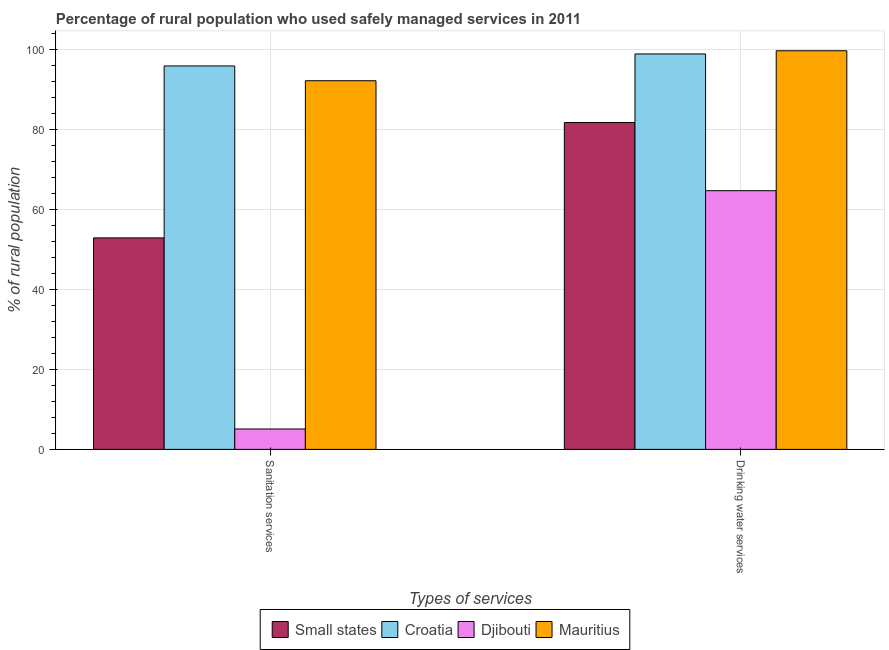How many different coloured bars are there?
Make the answer very short. 4. Are the number of bars on each tick of the X-axis equal?
Ensure brevity in your answer.  Yes. How many bars are there on the 2nd tick from the left?
Offer a very short reply. 4. How many bars are there on the 2nd tick from the right?
Your answer should be very brief. 4. What is the label of the 1st group of bars from the left?
Give a very brief answer. Sanitation services. What is the percentage of rural population who used sanitation services in Croatia?
Give a very brief answer. 95.9. Across all countries, what is the maximum percentage of rural population who used drinking water services?
Your answer should be very brief. 99.7. In which country was the percentage of rural population who used drinking water services maximum?
Make the answer very short. Mauritius. In which country was the percentage of rural population who used drinking water services minimum?
Keep it short and to the point. Djibouti. What is the total percentage of rural population who used sanitation services in the graph?
Your response must be concise. 246.1. What is the difference between the percentage of rural population who used drinking water services in Small states and that in Djibouti?
Your response must be concise. 17.06. What is the difference between the percentage of rural population who used sanitation services in Croatia and the percentage of rural population who used drinking water services in Small states?
Make the answer very short. 14.14. What is the average percentage of rural population who used drinking water services per country?
Provide a succinct answer. 86.26. What is the difference between the percentage of rural population who used drinking water services and percentage of rural population who used sanitation services in Croatia?
Offer a terse response. 3. In how many countries, is the percentage of rural population who used drinking water services greater than 44 %?
Offer a terse response. 4. What is the ratio of the percentage of rural population who used sanitation services in Djibouti to that in Small states?
Offer a terse response. 0.1. Is the percentage of rural population who used drinking water services in Small states less than that in Djibouti?
Keep it short and to the point. No. What does the 4th bar from the left in Drinking water services represents?
Provide a short and direct response. Mauritius. What does the 1st bar from the right in Drinking water services represents?
Provide a short and direct response. Mauritius. Are all the bars in the graph horizontal?
Give a very brief answer. No. What is the difference between two consecutive major ticks on the Y-axis?
Offer a terse response. 20. Does the graph contain any zero values?
Your answer should be compact. No. Where does the legend appear in the graph?
Offer a terse response. Bottom center. How many legend labels are there?
Offer a terse response. 4. How are the legend labels stacked?
Your answer should be compact. Horizontal. What is the title of the graph?
Your response must be concise. Percentage of rural population who used safely managed services in 2011. What is the label or title of the X-axis?
Keep it short and to the point. Types of services. What is the label or title of the Y-axis?
Your answer should be compact. % of rural population. What is the % of rural population of Small states in Sanitation services?
Offer a very short reply. 52.9. What is the % of rural population of Croatia in Sanitation services?
Ensure brevity in your answer.  95.9. What is the % of rural population in Mauritius in Sanitation services?
Offer a terse response. 92.2. What is the % of rural population of Small states in Drinking water services?
Your answer should be very brief. 81.76. What is the % of rural population in Croatia in Drinking water services?
Offer a very short reply. 98.9. What is the % of rural population of Djibouti in Drinking water services?
Provide a short and direct response. 64.7. What is the % of rural population in Mauritius in Drinking water services?
Make the answer very short. 99.7. Across all Types of services, what is the maximum % of rural population of Small states?
Provide a short and direct response. 81.76. Across all Types of services, what is the maximum % of rural population of Croatia?
Your answer should be very brief. 98.9. Across all Types of services, what is the maximum % of rural population of Djibouti?
Provide a short and direct response. 64.7. Across all Types of services, what is the maximum % of rural population in Mauritius?
Provide a short and direct response. 99.7. Across all Types of services, what is the minimum % of rural population in Small states?
Your answer should be compact. 52.9. Across all Types of services, what is the minimum % of rural population in Croatia?
Your answer should be very brief. 95.9. Across all Types of services, what is the minimum % of rural population of Djibouti?
Offer a very short reply. 5.1. Across all Types of services, what is the minimum % of rural population in Mauritius?
Give a very brief answer. 92.2. What is the total % of rural population in Small states in the graph?
Ensure brevity in your answer.  134.66. What is the total % of rural population in Croatia in the graph?
Offer a terse response. 194.8. What is the total % of rural population in Djibouti in the graph?
Offer a very short reply. 69.8. What is the total % of rural population in Mauritius in the graph?
Offer a very short reply. 191.9. What is the difference between the % of rural population of Small states in Sanitation services and that in Drinking water services?
Give a very brief answer. -28.86. What is the difference between the % of rural population in Croatia in Sanitation services and that in Drinking water services?
Provide a succinct answer. -3. What is the difference between the % of rural population in Djibouti in Sanitation services and that in Drinking water services?
Keep it short and to the point. -59.6. What is the difference between the % of rural population of Small states in Sanitation services and the % of rural population of Croatia in Drinking water services?
Offer a very short reply. -46. What is the difference between the % of rural population of Small states in Sanitation services and the % of rural population of Djibouti in Drinking water services?
Offer a very short reply. -11.8. What is the difference between the % of rural population of Small states in Sanitation services and the % of rural population of Mauritius in Drinking water services?
Give a very brief answer. -46.8. What is the difference between the % of rural population in Croatia in Sanitation services and the % of rural population in Djibouti in Drinking water services?
Provide a short and direct response. 31.2. What is the difference between the % of rural population in Croatia in Sanitation services and the % of rural population in Mauritius in Drinking water services?
Your answer should be compact. -3.8. What is the difference between the % of rural population in Djibouti in Sanitation services and the % of rural population in Mauritius in Drinking water services?
Keep it short and to the point. -94.6. What is the average % of rural population in Small states per Types of services?
Your answer should be compact. 67.33. What is the average % of rural population in Croatia per Types of services?
Ensure brevity in your answer.  97.4. What is the average % of rural population in Djibouti per Types of services?
Make the answer very short. 34.9. What is the average % of rural population of Mauritius per Types of services?
Give a very brief answer. 95.95. What is the difference between the % of rural population of Small states and % of rural population of Croatia in Sanitation services?
Ensure brevity in your answer.  -43. What is the difference between the % of rural population of Small states and % of rural population of Djibouti in Sanitation services?
Give a very brief answer. 47.8. What is the difference between the % of rural population in Small states and % of rural population in Mauritius in Sanitation services?
Your answer should be very brief. -39.3. What is the difference between the % of rural population in Croatia and % of rural population in Djibouti in Sanitation services?
Provide a short and direct response. 90.8. What is the difference between the % of rural population in Djibouti and % of rural population in Mauritius in Sanitation services?
Provide a short and direct response. -87.1. What is the difference between the % of rural population in Small states and % of rural population in Croatia in Drinking water services?
Ensure brevity in your answer.  -17.14. What is the difference between the % of rural population in Small states and % of rural population in Djibouti in Drinking water services?
Your response must be concise. 17.06. What is the difference between the % of rural population in Small states and % of rural population in Mauritius in Drinking water services?
Provide a short and direct response. -17.94. What is the difference between the % of rural population in Croatia and % of rural population in Djibouti in Drinking water services?
Offer a very short reply. 34.2. What is the difference between the % of rural population of Djibouti and % of rural population of Mauritius in Drinking water services?
Your response must be concise. -35. What is the ratio of the % of rural population in Small states in Sanitation services to that in Drinking water services?
Ensure brevity in your answer.  0.65. What is the ratio of the % of rural population of Croatia in Sanitation services to that in Drinking water services?
Your response must be concise. 0.97. What is the ratio of the % of rural population of Djibouti in Sanitation services to that in Drinking water services?
Provide a short and direct response. 0.08. What is the ratio of the % of rural population in Mauritius in Sanitation services to that in Drinking water services?
Provide a succinct answer. 0.92. What is the difference between the highest and the second highest % of rural population of Small states?
Make the answer very short. 28.86. What is the difference between the highest and the second highest % of rural population of Djibouti?
Provide a succinct answer. 59.6. What is the difference between the highest and the lowest % of rural population of Small states?
Offer a terse response. 28.86. What is the difference between the highest and the lowest % of rural population of Djibouti?
Offer a very short reply. 59.6. What is the difference between the highest and the lowest % of rural population in Mauritius?
Provide a succinct answer. 7.5. 